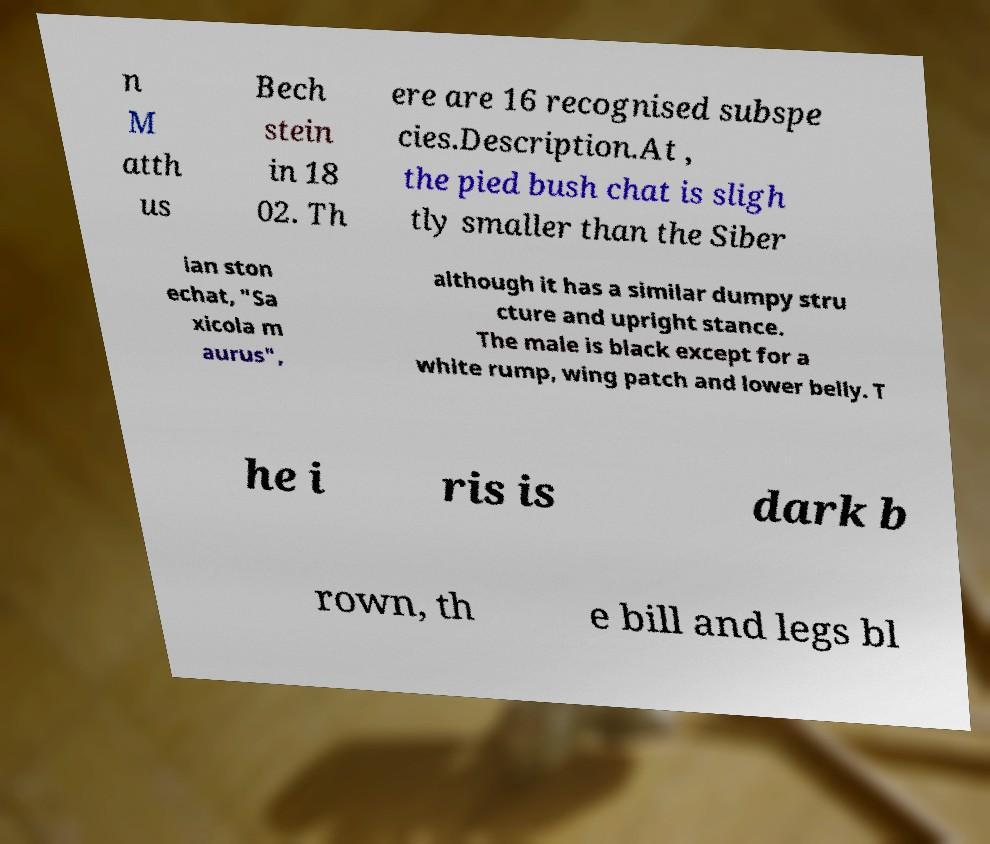Please read and relay the text visible in this image. What does it say? n M atth us Bech stein in 18 02. Th ere are 16 recognised subspe cies.Description.At , the pied bush chat is sligh tly smaller than the Siber ian ston echat, "Sa xicola m aurus", although it has a similar dumpy stru cture and upright stance. The male is black except for a white rump, wing patch and lower belly. T he i ris is dark b rown, th e bill and legs bl 